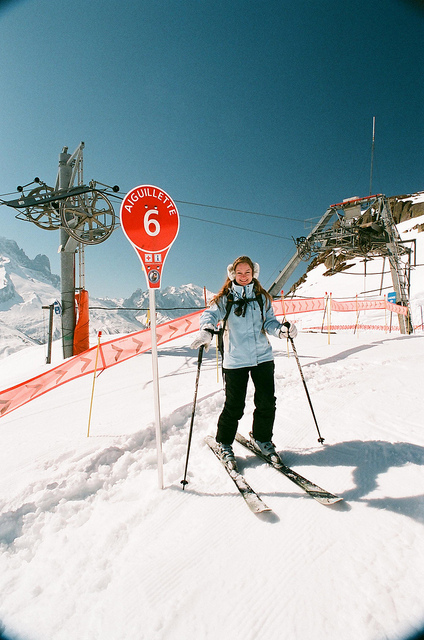Extract all visible text content from this image. AIGUILLETTE 6 